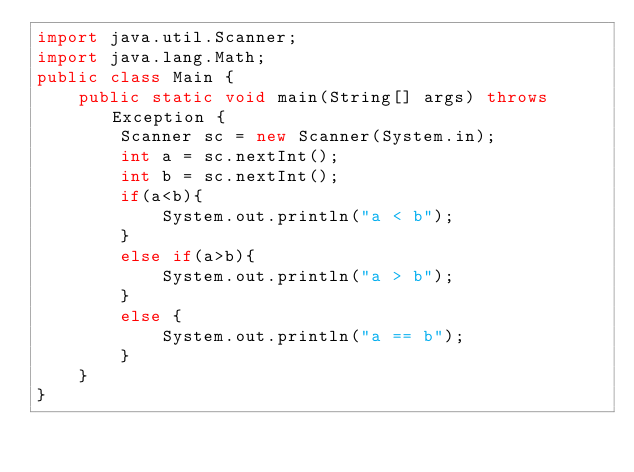<code> <loc_0><loc_0><loc_500><loc_500><_Java_>import java.util.Scanner;
import java.lang.Math;
public class Main {
    public static void main(String[] args) throws Exception {
        Scanner sc = new Scanner(System.in);
        int a = sc.nextInt();
        int b = sc.nextInt();
        if(a<b){
            System.out.println("a < b");
        }
        else if(a>b){
            System.out.println("a > b");
        }
        else {
            System.out.println("a == b");
        }
    }
}
</code> 